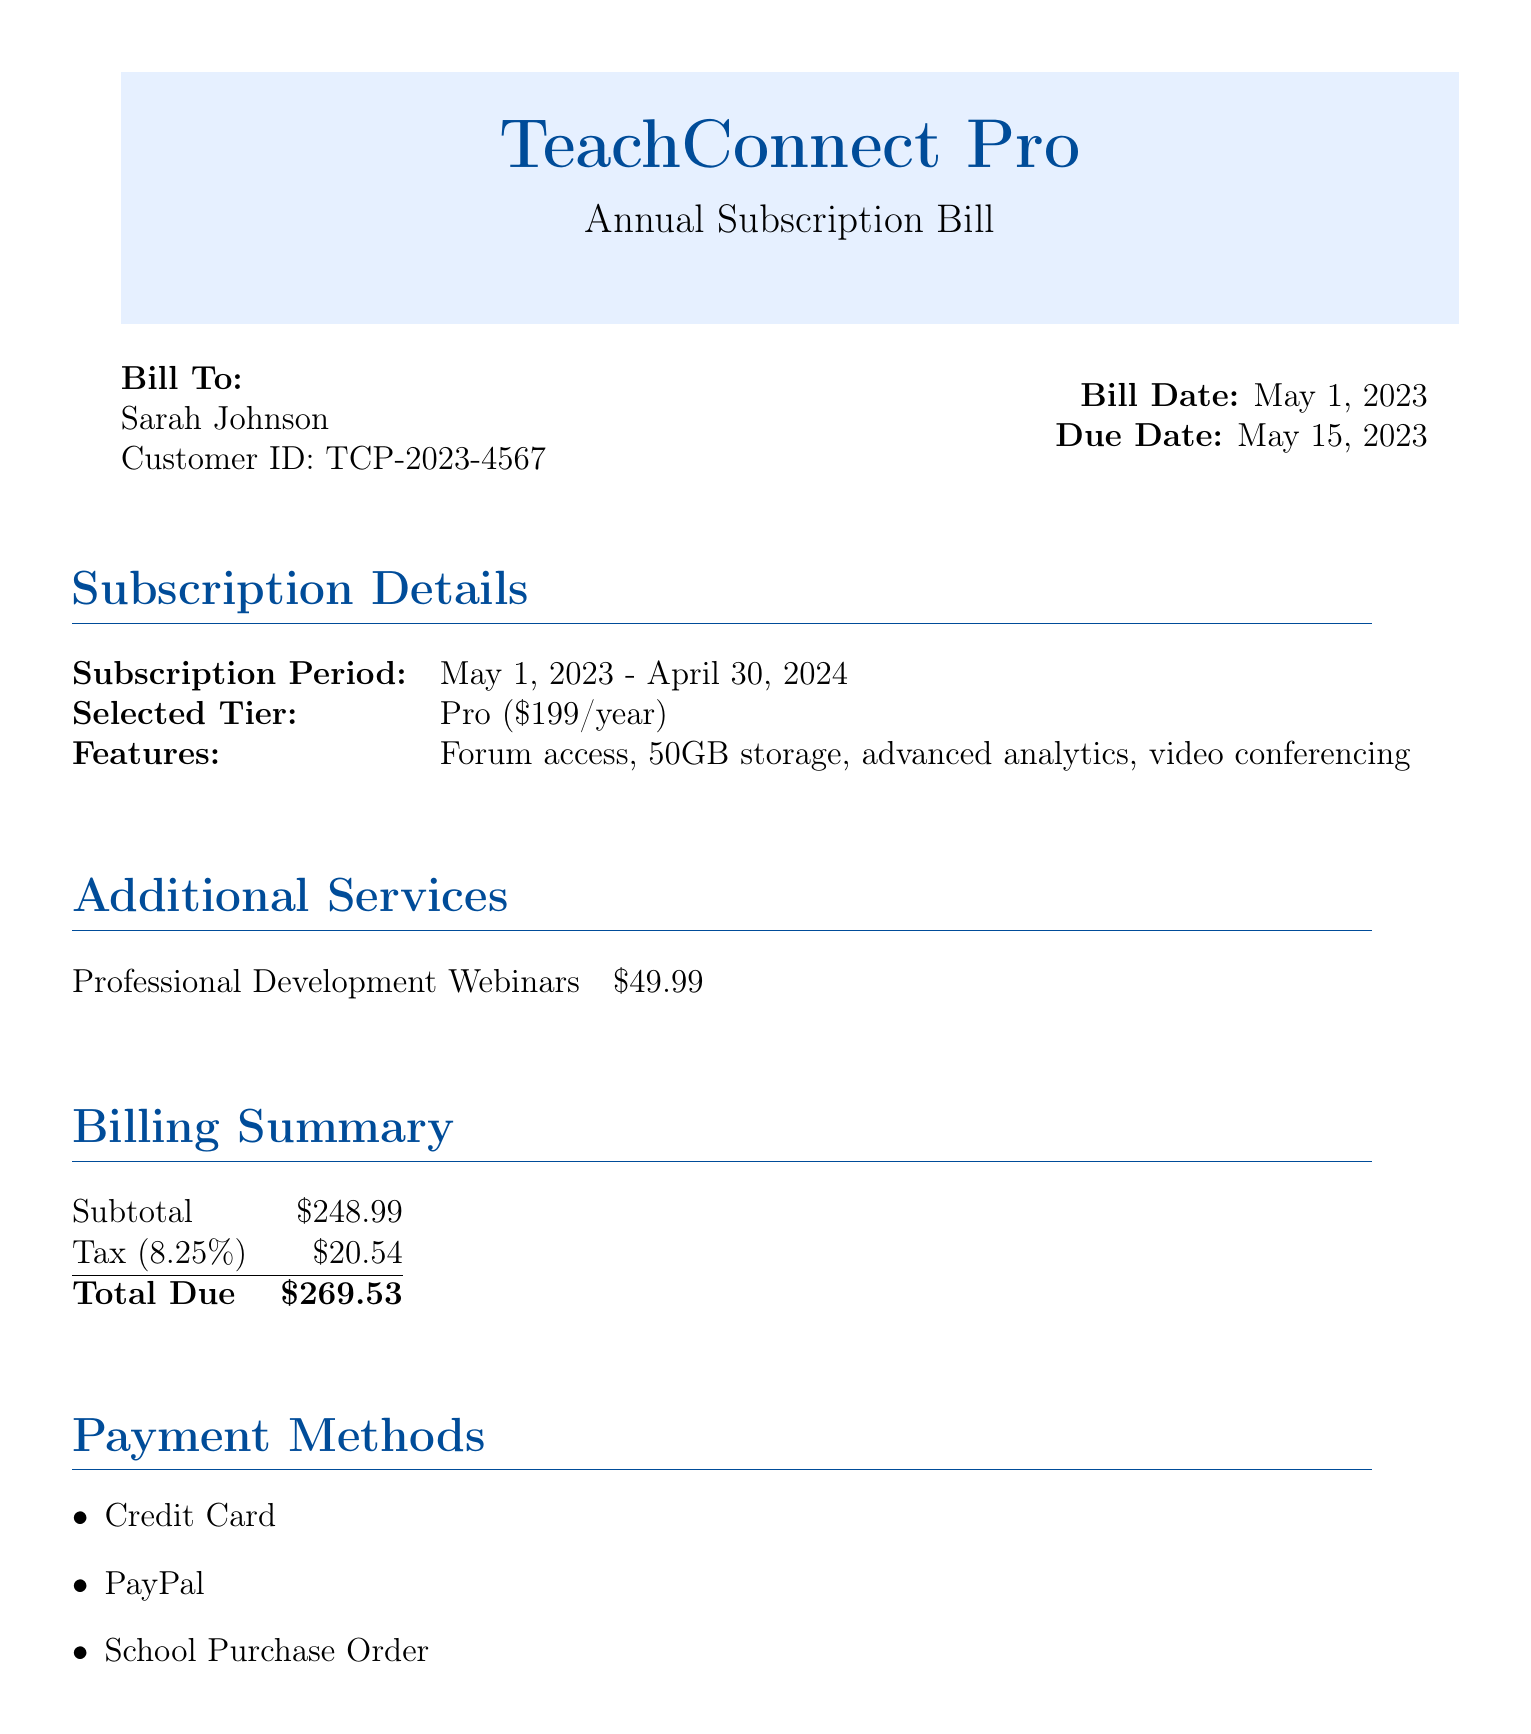What is the customer ID? The customer ID is mentioned in the bill to identify the customer, which is TCP-2023-4567.
Answer: TCP-2023-4567 What is the selected tier? The document specifies the selected tier for the subscription as Pro, including the price per year.
Answer: Pro ($199/year) When is the due date for the payment? The due date is specified in the billing section of the document, which is 15 days after the bill date.
Answer: May 15, 2023 What are the additional services listed? The additional services section details any extra offerings, which includes a specific professional development service and its price.
Answer: Professional Development Webinars What is the subtotal amount? The subtotal amount is part of the billing summary, presenting the total before tax is applied.
Answer: $248.99 What is the tax percentage applied? The document notes the tax percentage in the billing summary, which is mentioned clearly as a percentage.
Answer: 8.25% What are the payment methods available? The payment methods are listed in a bullet-point format, showing the options a customer can choose from to complete their payment.
Answer: Credit Card, PayPal, School Purchase Order What is the total due amount? The total due is the final amount calculated after adding tax to the subtotal, clearly stated in the billing summary.
Answer: $269.53 What is the email contact for support? The support contact information includes an email address for customer inquiries or assistance.
Answer: support@teachconnectpro.com 